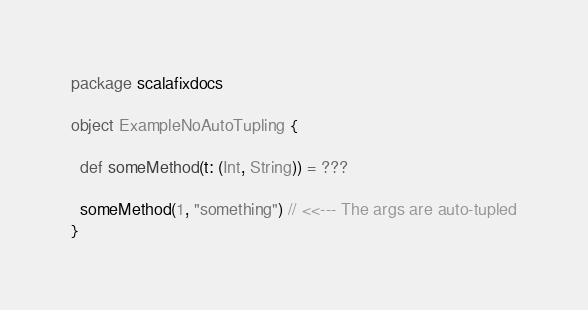<code> <loc_0><loc_0><loc_500><loc_500><_Scala_>package scalafixdocs

object ExampleNoAutoTupling {

  def someMethod(t: (Int, String)) = ???

  someMethod(1, "something") // <<--- The args are auto-tupled
}</code> 